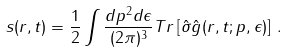Convert formula to latex. <formula><loc_0><loc_0><loc_500><loc_500>s ( r , t ) = \frac { 1 } { 2 } \int \frac { d p ^ { 2 } d \epsilon } { ( 2 \pi ) ^ { 3 } } T r \left [ \hat { \sigma } \hat { g } ( r , t ; p , \epsilon ) \right ] \, .</formula> 